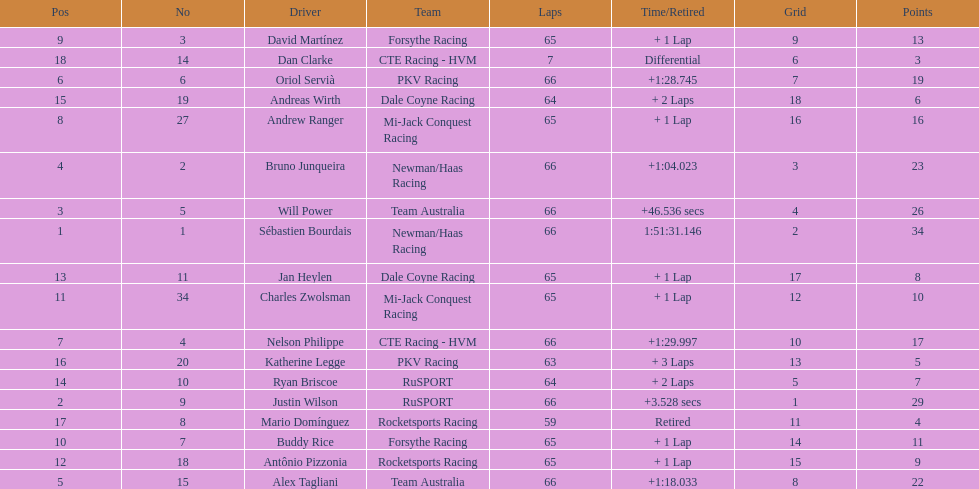At the 2006 gran premio telmex, how many drivers completed less than 60 laps? 2. 